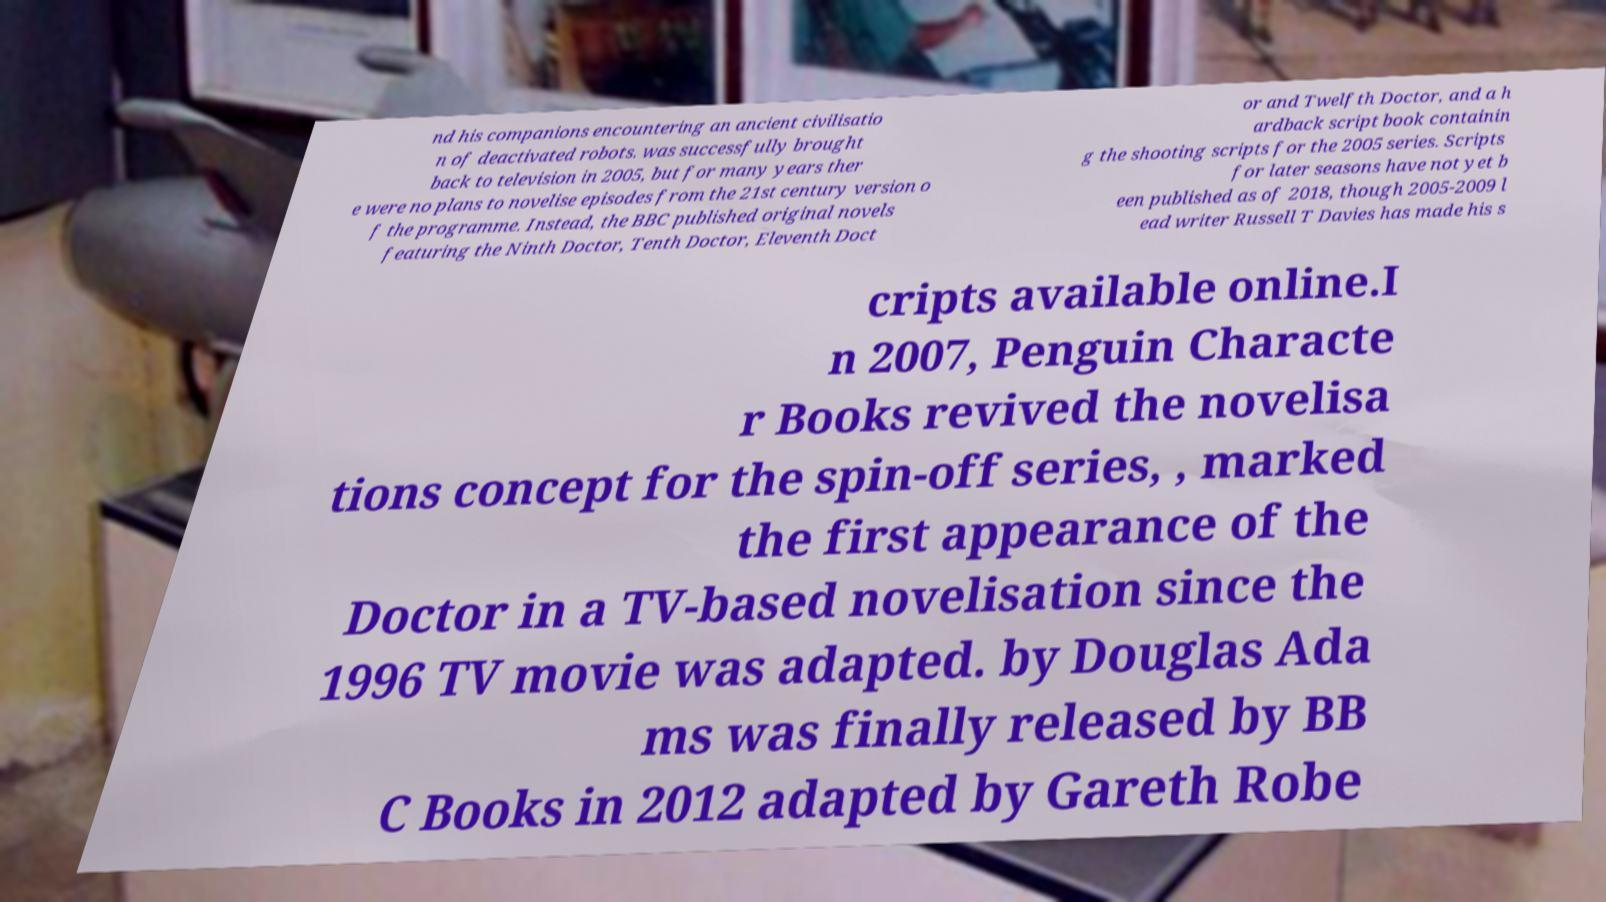Can you accurately transcribe the text from the provided image for me? nd his companions encountering an ancient civilisatio n of deactivated robots. was successfully brought back to television in 2005, but for many years ther e were no plans to novelise episodes from the 21st century version o f the programme. Instead, the BBC published original novels featuring the Ninth Doctor, Tenth Doctor, Eleventh Doct or and Twelfth Doctor, and a h ardback script book containin g the shooting scripts for the 2005 series. Scripts for later seasons have not yet b een published as of 2018, though 2005-2009 l ead writer Russell T Davies has made his s cripts available online.I n 2007, Penguin Characte r Books revived the novelisa tions concept for the spin-off series, , marked the first appearance of the Doctor in a TV-based novelisation since the 1996 TV movie was adapted. by Douglas Ada ms was finally released by BB C Books in 2012 adapted by Gareth Robe 